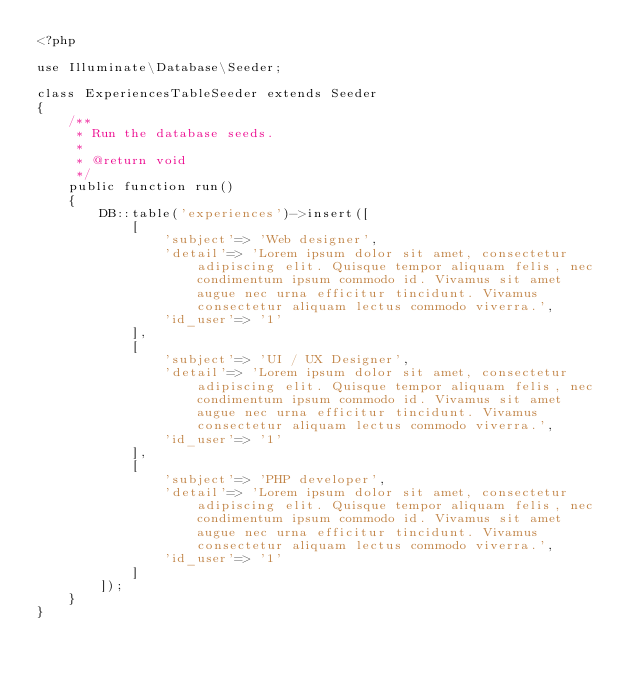<code> <loc_0><loc_0><loc_500><loc_500><_PHP_><?php

use Illuminate\Database\Seeder;

class ExperiencesTableSeeder extends Seeder
{
    /**
     * Run the database seeds.
     *
     * @return void
     */
    public function run()
    {
        DB::table('experiences')->insert([
            [
                'subject'=> 'Web designer',
                'detail'=> 'Lorem ipsum dolor sit amet, consectetur adipiscing elit. Quisque tempor aliquam felis, nec condimentum ipsum commodo id. Vivamus sit amet augue nec urna efficitur tincidunt. Vivamus consectetur aliquam lectus commodo viverra.',
                'id_user'=> '1'
            ],
            [
                'subject'=> 'UI / UX Designer',
                'detail'=> 'Lorem ipsum dolor sit amet, consectetur adipiscing elit. Quisque tempor aliquam felis, nec condimentum ipsum commodo id. Vivamus sit amet augue nec urna efficitur tincidunt. Vivamus consectetur aliquam lectus commodo viverra.',
                'id_user'=> '1'
            ],
            [
                'subject'=> 'PHP developer',
                'detail'=> 'Lorem ipsum dolor sit amet, consectetur adipiscing elit. Quisque tempor aliquam felis, nec condimentum ipsum commodo id. Vivamus sit amet augue nec urna efficitur tincidunt. Vivamus consectetur aliquam lectus commodo viverra.',
                'id_user'=> '1'
            ]
        ]);
    }
}
</code> 